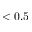<formula> <loc_0><loc_0><loc_500><loc_500>< 0 . 5</formula> 